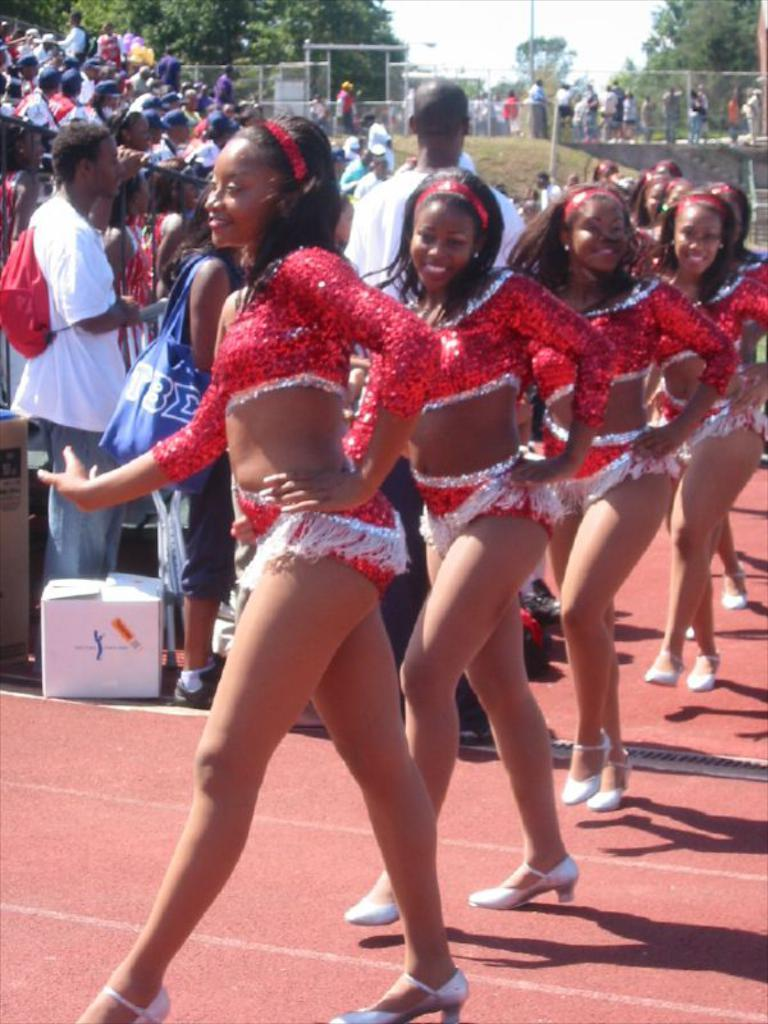What is the main subject of the image? The main subject of the image is a group of women. What are the women wearing in the image? The women are wearing red dresses in the image. What are the women doing in the image? The women are dancing on a path in the image. Can you describe the background of the image? In the background of the image, there are groups of people, a cardboard box, a fence, trees, and the sky. How many cells can be seen in the image? There are no cells visible in the image; it features a group of women dancing on a path. What type of snail is crawling on the fence in the image? There is no snail present on the fence in the image. 